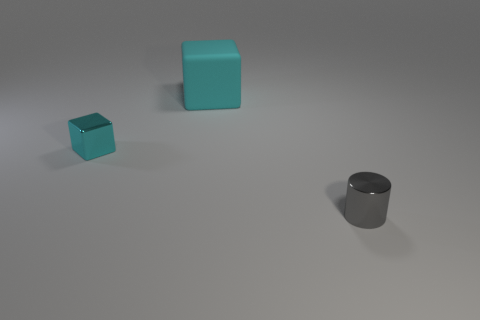Add 2 gray objects. How many objects exist? 5 Subtract all blocks. How many objects are left? 1 Subtract 1 cylinders. How many cylinders are left? 0 Subtract all yellow cylinders. Subtract all yellow blocks. How many cylinders are left? 1 Subtract all purple cylinders. How many green blocks are left? 0 Subtract all big cyan matte cubes. Subtract all metallic objects. How many objects are left? 0 Add 2 rubber blocks. How many rubber blocks are left? 3 Add 3 big matte blocks. How many big matte blocks exist? 4 Subtract 0 green spheres. How many objects are left? 3 